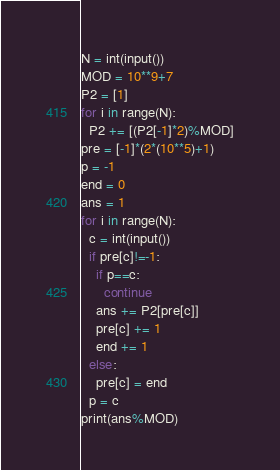<code> <loc_0><loc_0><loc_500><loc_500><_Python_>N = int(input())
MOD = 10**9+7
P2 = [1]
for i in range(N):
  P2 += [(P2[-1]*2)%MOD]
pre = [-1]*(2*(10**5)+1)
p = -1
end = 0
ans = 1
for i in range(N):
  c = int(input())
  if pre[c]!=-1:
    if p==c:
      continue
    ans += P2[pre[c]]
    pre[c] += 1
    end += 1
  else:
    pre[c] = end
  p = c
print(ans%MOD)</code> 